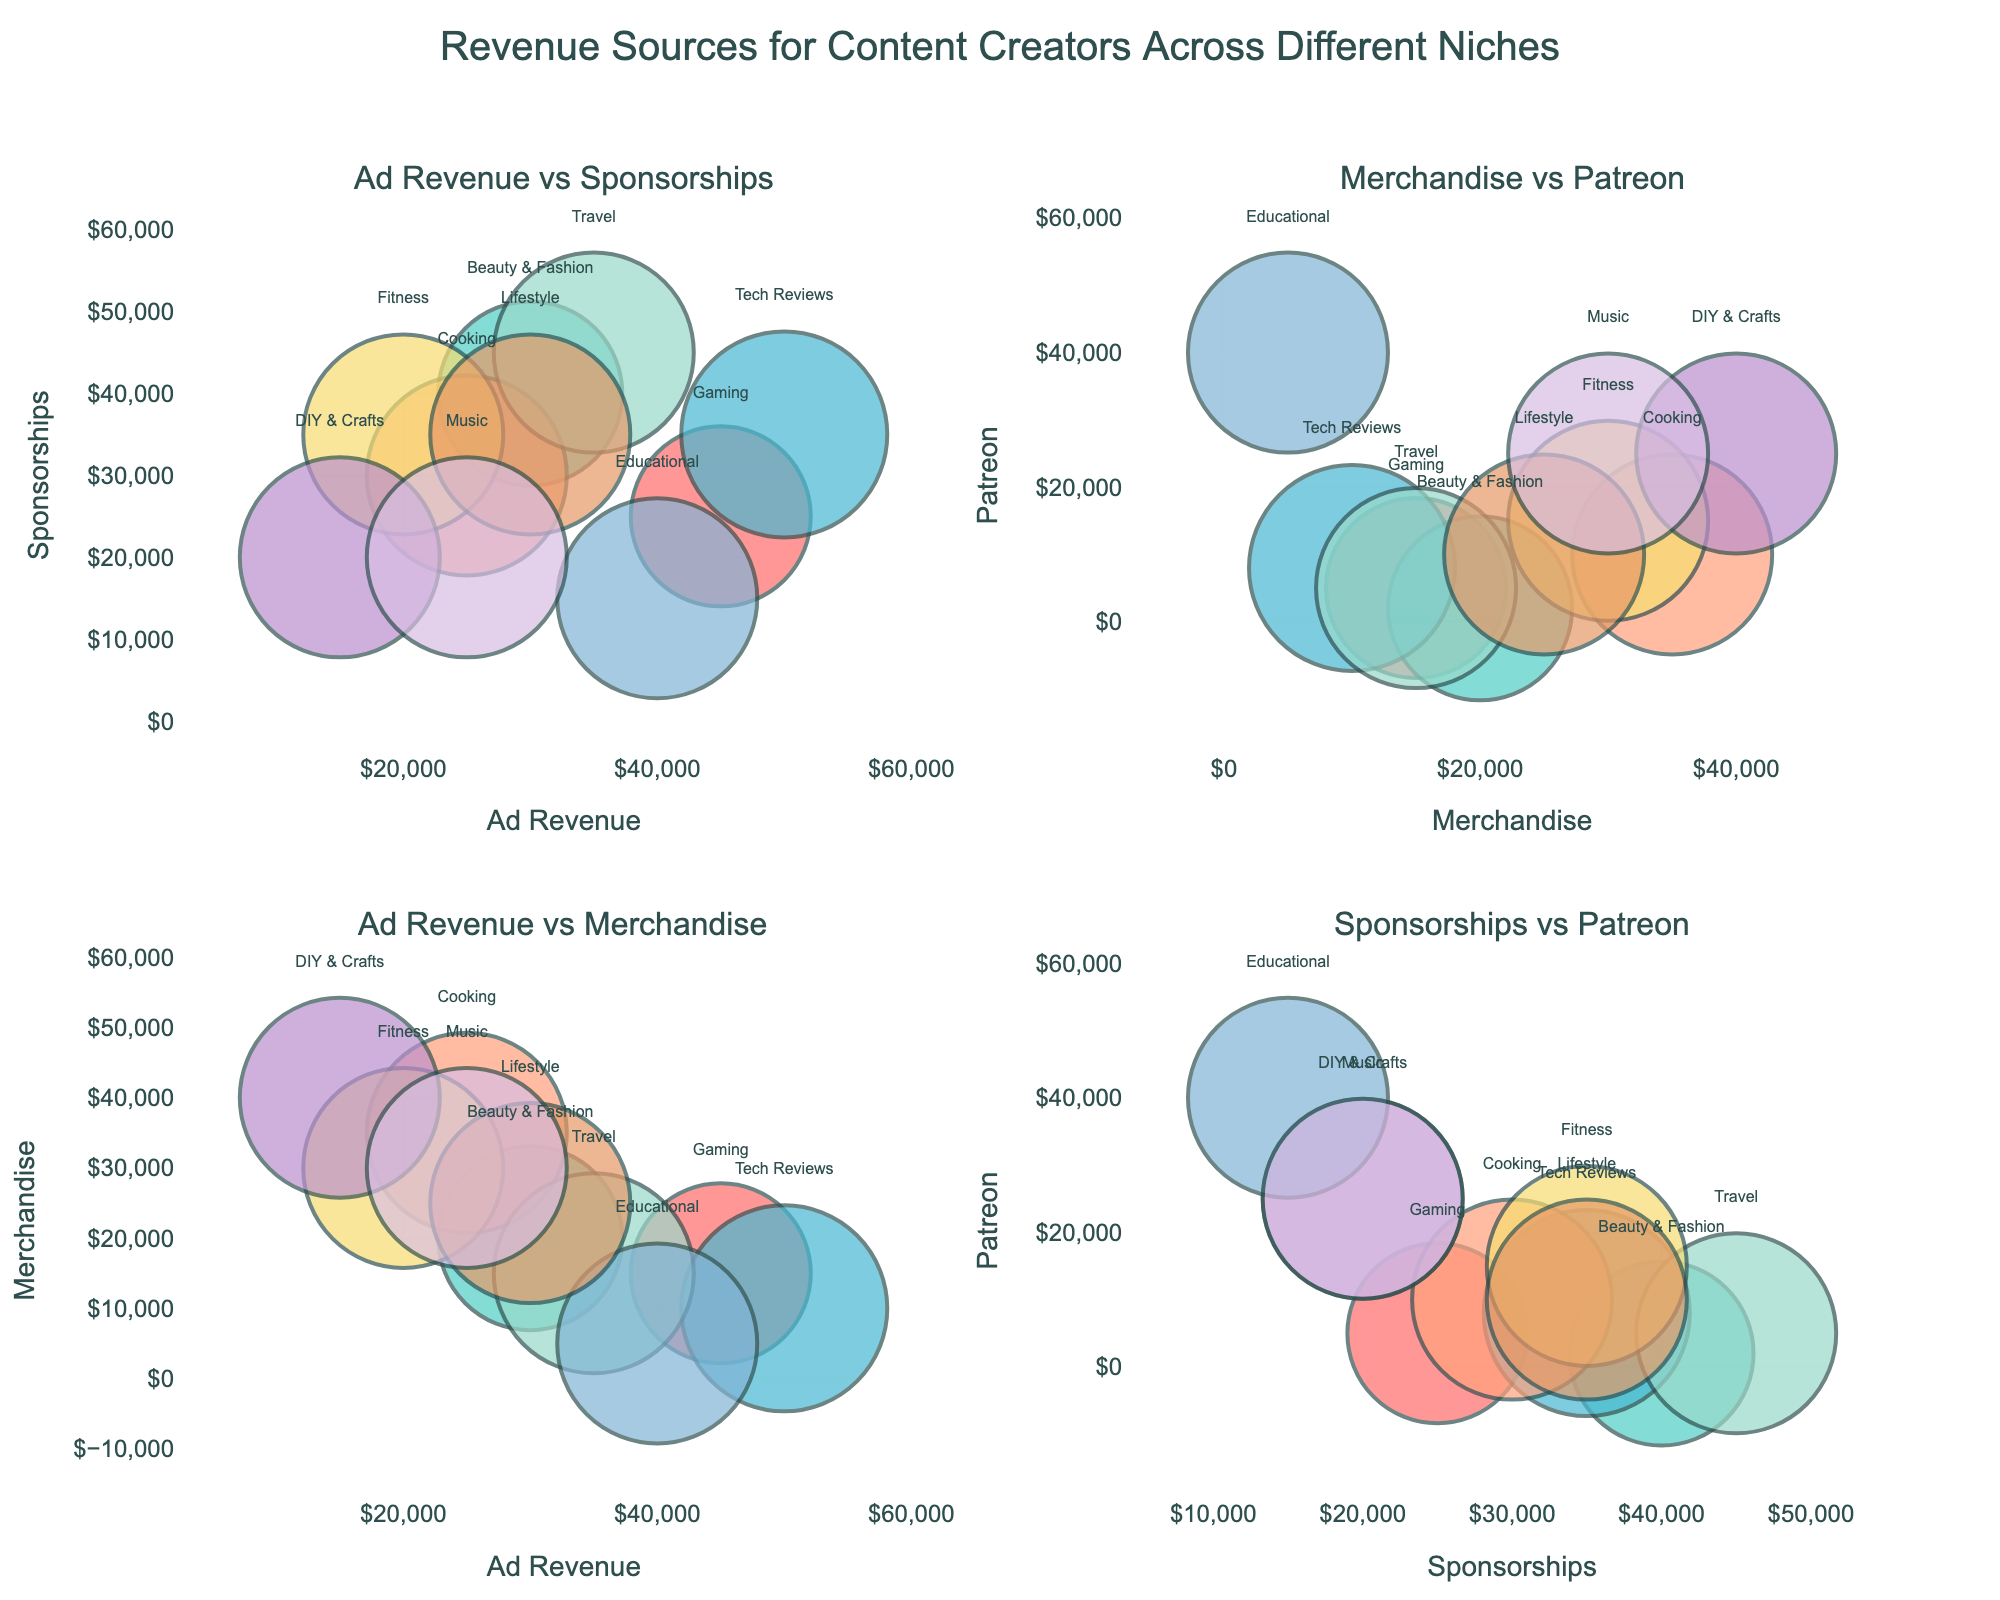What does the bubble size represent in all the subplots? The bubble size represents the total income of content creators across different niches. This is visually indicated as larger bubbles for greater total income and smaller bubbles for lesser total income.
Answer: Total income Which niche has the highest total income? The Tech Reviews niche has the highest total income. This can be observed as the largest bubble across all subplots. The largest bubble corresponds to the Tech Reviews niche due to their highest total income of $103,000.
Answer: Tech Reviews How would you describe the relationship between Ad Revenue and Sponsorships for the niches? The Ad Revenue vs Sponsorships subplot shows an overall positive relationship where niches with higher ad revenue generally also have higher sponsorship revenue. For example, Tech Reviews and Travel niches show both high ad revenue and sponsorship incomes.
Answer: Positive relationship Which niche has maximum Patreon revenue and what is the corresponding total income? The Educational niche exhibits the maximum Patreon revenue with a total income of $100,000. This can be observed as the point with the highest value on the Patreon axis in the relevant subplots ('Merchandise vs Patreon' and 'Sponsorships vs Patreon').
Answer: Educational, $100,000 Which niche has a lower total income: DIY & Crafts or Gaming? The DIY & Crafts niche has a lower total income compared to Gaming. Although both niches have a total income of $100,000, Gaming has a higher total income of $90,000, as observed from the smaller bubble size for DIY & Crafts in comparison to Gaming.
Answer: DIY & Crafts How do the Fitness and Lifestyle niches compare in terms of Merchandise revenue? Both Fitness and Lifestyle niches appear side by side on the Merchandise axis in the 'Ad Revenue vs Merchandise' and 'Merchandise vs Patreon' subplots, with both having equal Merchandise revenues of $30,000. Therefore, they are equal in terms of Merchandise revenue.
Answer: Equal In the 'Ad Revenue vs Sponsorships' subplot, which niche is seated on the midpoint of Sponsorship axis? The Music niche sits on the midpoint of the Sponsorship axis in the 'Ad Revenue vs Sponsorships' subplot, having $20,000 in sponsorship revenue, which is the midway point of the scale.
Answer: Music What is the combined total income of the Travel and Cooking niches? The combined total income of the Travel and Cooking niches is calculated by summing up their individual total incomes: $100,000 (Travel) and $100,000 (Cooking), equaling $200,000.
Answer: $200,000 Name two niches with total income of $100,000 that have the highest sponsorship revenue. Travel and Fitness niches both have a total income of $100,000 and exhibit the highest sponsorship revenues amongst niches sharing the same total income. This is evident from their larger bubble sizes and higher y-axis positions on the 'Ad Revenue vs Sponsorships' subplot.
Answer: Travel, Fitness 